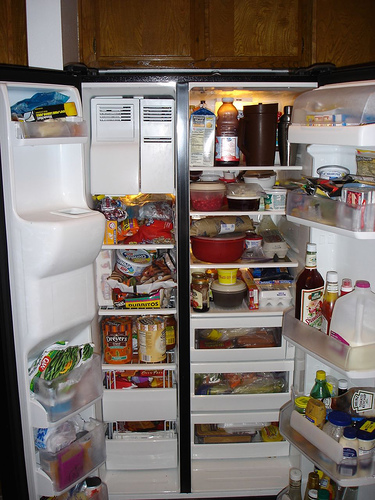<image>How much milk is left in the jug? I am not sure how much milk is left in the jug. The amount can vary, possibly around half. How much milk is left in the jug? The jug is half full of milk. 